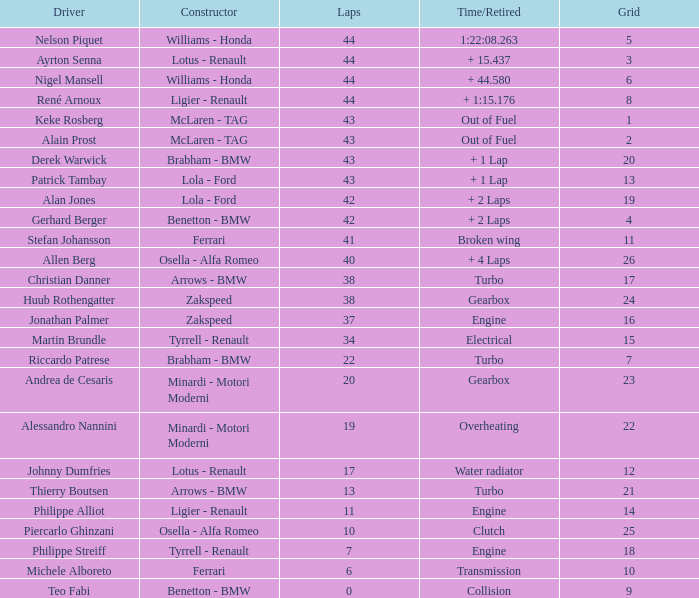I desire the driver with 10 laps. Piercarlo Ghinzani. 